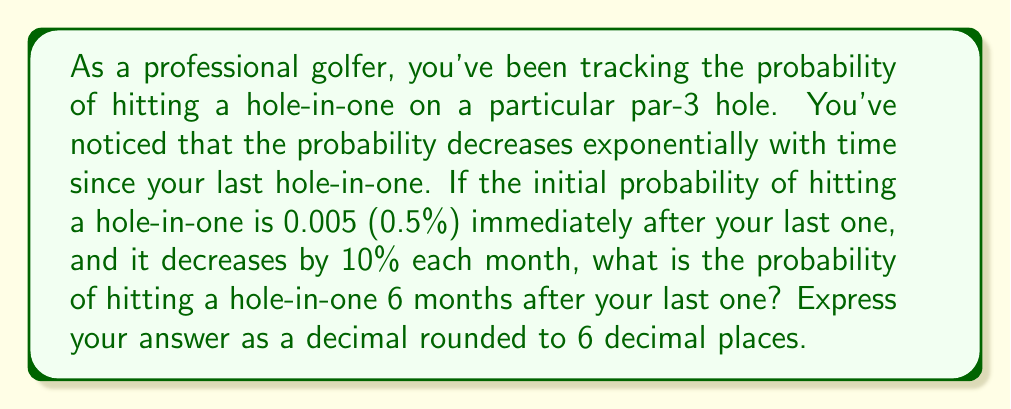Give your solution to this math problem. Let's approach this step-by-step:

1) We're dealing with an exponential decay function. The general form is:

   $$ P(t) = P_0 \cdot (1-r)^t $$

   Where:
   $P(t)$ is the probability at time $t$
   $P_0$ is the initial probability
   $r$ is the rate of decay per unit time
   $t$ is the time elapsed

2) We know:
   $P_0 = 0.005$ (initial probability)
   $r = 0.10$ (10% decrease per month)
   $t = 6$ (months)

3) Plugging these values into our equation:

   $$ P(6) = 0.005 \cdot (1-0.10)^6 $$

4) Simplify:
   $$ P(6) = 0.005 \cdot (0.9)^6 $$

5) Calculate:
   $$ P(6) = 0.005 \cdot 0.531441 $$
   $$ P(6) = 0.00265720... $$

6) Rounding to 6 decimal places:
   $$ P(6) \approx 0.002657 $$
Answer: 0.002657 